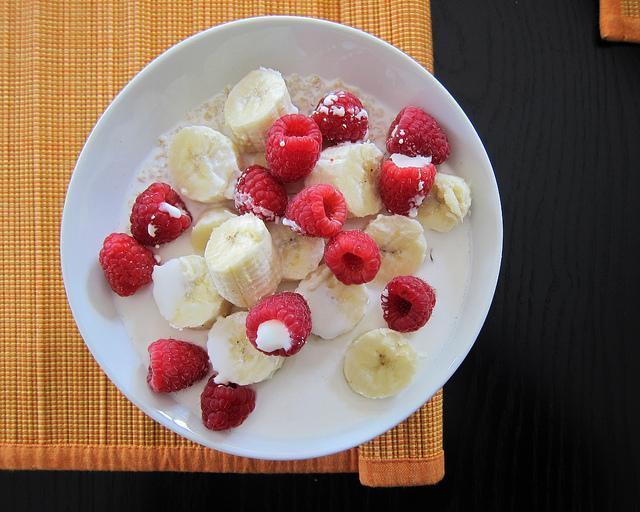How many strawberries are seen?
Give a very brief answer. 0. How many bananas are there?
Give a very brief answer. 7. How many white cows are there?
Give a very brief answer. 0. 